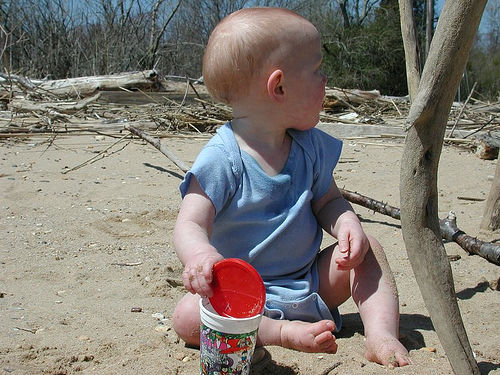<image>
Is the child next to the stick? Yes. The child is positioned adjacent to the stick, located nearby in the same general area. 